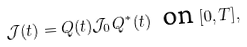<formula> <loc_0><loc_0><loc_500><loc_500>\mathcal { J } ( t ) = Q ( t ) \mathcal { J } _ { 0 } Q ^ { * } ( t ) \ \text { on } [ 0 , T ] ,</formula> 